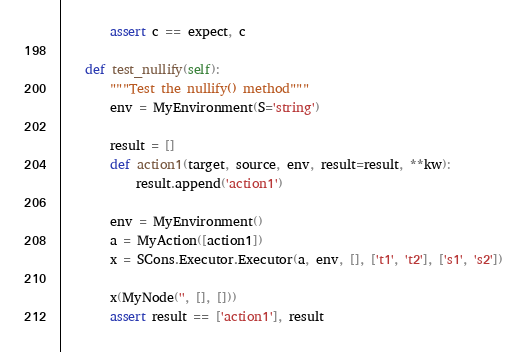Convert code to text. <code><loc_0><loc_0><loc_500><loc_500><_Python_>        assert c == expect, c

    def test_nullify(self):
        """Test the nullify() method"""
        env = MyEnvironment(S='string')

        result = []
        def action1(target, source, env, result=result, **kw):
            result.append('action1')

        env = MyEnvironment()
        a = MyAction([action1])
        x = SCons.Executor.Executor(a, env, [], ['t1', 't2'], ['s1', 's2'])

        x(MyNode('', [], []))
        assert result == ['action1'], result</code> 